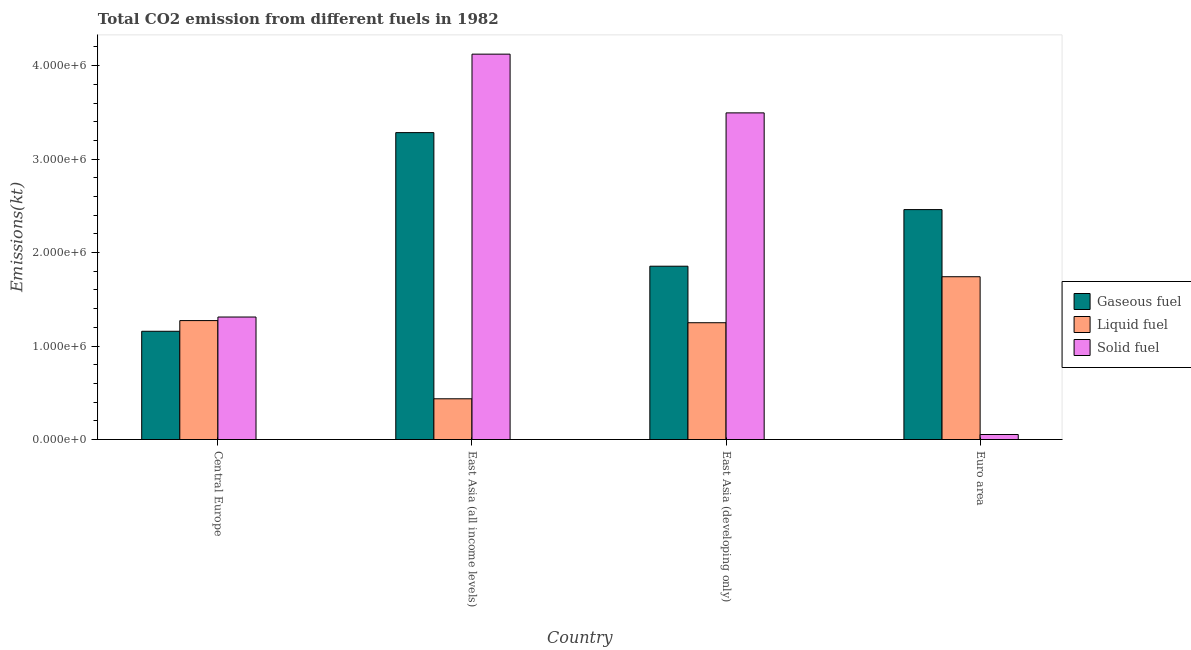How many different coloured bars are there?
Make the answer very short. 3. Are the number of bars per tick equal to the number of legend labels?
Provide a succinct answer. Yes. How many bars are there on the 4th tick from the left?
Ensure brevity in your answer.  3. What is the label of the 1st group of bars from the left?
Offer a terse response. Central Europe. What is the amount of co2 emissions from liquid fuel in East Asia (all income levels)?
Your response must be concise. 4.36e+05. Across all countries, what is the maximum amount of co2 emissions from solid fuel?
Your response must be concise. 4.12e+06. Across all countries, what is the minimum amount of co2 emissions from gaseous fuel?
Offer a terse response. 1.16e+06. In which country was the amount of co2 emissions from solid fuel maximum?
Give a very brief answer. East Asia (all income levels). In which country was the amount of co2 emissions from liquid fuel minimum?
Your answer should be very brief. East Asia (all income levels). What is the total amount of co2 emissions from solid fuel in the graph?
Ensure brevity in your answer.  8.98e+06. What is the difference between the amount of co2 emissions from liquid fuel in East Asia (all income levels) and that in Euro area?
Give a very brief answer. -1.31e+06. What is the difference between the amount of co2 emissions from gaseous fuel in Euro area and the amount of co2 emissions from liquid fuel in Central Europe?
Keep it short and to the point. 1.19e+06. What is the average amount of co2 emissions from gaseous fuel per country?
Keep it short and to the point. 2.19e+06. What is the difference between the amount of co2 emissions from liquid fuel and amount of co2 emissions from gaseous fuel in Euro area?
Provide a short and direct response. -7.18e+05. In how many countries, is the amount of co2 emissions from liquid fuel greater than 2800000 kt?
Offer a terse response. 0. What is the ratio of the amount of co2 emissions from solid fuel in East Asia (all income levels) to that in East Asia (developing only)?
Provide a short and direct response. 1.18. Is the amount of co2 emissions from solid fuel in East Asia (developing only) less than that in Euro area?
Offer a terse response. No. What is the difference between the highest and the second highest amount of co2 emissions from solid fuel?
Offer a terse response. 6.28e+05. What is the difference between the highest and the lowest amount of co2 emissions from liquid fuel?
Offer a terse response. 1.31e+06. Is the sum of the amount of co2 emissions from liquid fuel in Central Europe and East Asia (all income levels) greater than the maximum amount of co2 emissions from solid fuel across all countries?
Give a very brief answer. No. What does the 2nd bar from the left in Central Europe represents?
Your response must be concise. Liquid fuel. What does the 3rd bar from the right in East Asia (developing only) represents?
Make the answer very short. Gaseous fuel. How many bars are there?
Your response must be concise. 12. Are all the bars in the graph horizontal?
Offer a very short reply. No. How many countries are there in the graph?
Give a very brief answer. 4. Are the values on the major ticks of Y-axis written in scientific E-notation?
Your answer should be compact. Yes. Where does the legend appear in the graph?
Provide a short and direct response. Center right. How many legend labels are there?
Provide a succinct answer. 3. What is the title of the graph?
Your answer should be compact. Total CO2 emission from different fuels in 1982. Does "Total employers" appear as one of the legend labels in the graph?
Offer a very short reply. No. What is the label or title of the Y-axis?
Your response must be concise. Emissions(kt). What is the Emissions(kt) in Gaseous fuel in Central Europe?
Your response must be concise. 1.16e+06. What is the Emissions(kt) in Liquid fuel in Central Europe?
Your response must be concise. 1.27e+06. What is the Emissions(kt) in Solid fuel in Central Europe?
Your response must be concise. 1.31e+06. What is the Emissions(kt) of Gaseous fuel in East Asia (all income levels)?
Ensure brevity in your answer.  3.28e+06. What is the Emissions(kt) in Liquid fuel in East Asia (all income levels)?
Make the answer very short. 4.36e+05. What is the Emissions(kt) of Solid fuel in East Asia (all income levels)?
Offer a very short reply. 4.12e+06. What is the Emissions(kt) in Gaseous fuel in East Asia (developing only)?
Your answer should be very brief. 1.85e+06. What is the Emissions(kt) in Liquid fuel in East Asia (developing only)?
Offer a very short reply. 1.25e+06. What is the Emissions(kt) in Solid fuel in East Asia (developing only)?
Your answer should be very brief. 3.49e+06. What is the Emissions(kt) in Gaseous fuel in Euro area?
Provide a succinct answer. 2.46e+06. What is the Emissions(kt) of Liquid fuel in Euro area?
Offer a very short reply. 1.74e+06. What is the Emissions(kt) of Solid fuel in Euro area?
Your answer should be very brief. 5.37e+04. Across all countries, what is the maximum Emissions(kt) in Gaseous fuel?
Ensure brevity in your answer.  3.28e+06. Across all countries, what is the maximum Emissions(kt) in Liquid fuel?
Make the answer very short. 1.74e+06. Across all countries, what is the maximum Emissions(kt) of Solid fuel?
Provide a succinct answer. 4.12e+06. Across all countries, what is the minimum Emissions(kt) in Gaseous fuel?
Your answer should be very brief. 1.16e+06. Across all countries, what is the minimum Emissions(kt) of Liquid fuel?
Offer a very short reply. 4.36e+05. Across all countries, what is the minimum Emissions(kt) in Solid fuel?
Offer a terse response. 5.37e+04. What is the total Emissions(kt) of Gaseous fuel in the graph?
Your answer should be compact. 8.76e+06. What is the total Emissions(kt) in Liquid fuel in the graph?
Keep it short and to the point. 4.70e+06. What is the total Emissions(kt) in Solid fuel in the graph?
Ensure brevity in your answer.  8.98e+06. What is the difference between the Emissions(kt) in Gaseous fuel in Central Europe and that in East Asia (all income levels)?
Make the answer very short. -2.13e+06. What is the difference between the Emissions(kt) of Liquid fuel in Central Europe and that in East Asia (all income levels)?
Make the answer very short. 8.37e+05. What is the difference between the Emissions(kt) in Solid fuel in Central Europe and that in East Asia (all income levels)?
Make the answer very short. -2.81e+06. What is the difference between the Emissions(kt) of Gaseous fuel in Central Europe and that in East Asia (developing only)?
Make the answer very short. -6.96e+05. What is the difference between the Emissions(kt) in Liquid fuel in Central Europe and that in East Asia (developing only)?
Give a very brief answer. 2.29e+04. What is the difference between the Emissions(kt) of Solid fuel in Central Europe and that in East Asia (developing only)?
Offer a terse response. -2.18e+06. What is the difference between the Emissions(kt) in Gaseous fuel in Central Europe and that in Euro area?
Keep it short and to the point. -1.30e+06. What is the difference between the Emissions(kt) of Liquid fuel in Central Europe and that in Euro area?
Your response must be concise. -4.69e+05. What is the difference between the Emissions(kt) in Solid fuel in Central Europe and that in Euro area?
Your answer should be compact. 1.26e+06. What is the difference between the Emissions(kt) of Gaseous fuel in East Asia (all income levels) and that in East Asia (developing only)?
Provide a succinct answer. 1.43e+06. What is the difference between the Emissions(kt) of Liquid fuel in East Asia (all income levels) and that in East Asia (developing only)?
Make the answer very short. -8.14e+05. What is the difference between the Emissions(kt) in Solid fuel in East Asia (all income levels) and that in East Asia (developing only)?
Your answer should be very brief. 6.28e+05. What is the difference between the Emissions(kt) of Gaseous fuel in East Asia (all income levels) and that in Euro area?
Offer a very short reply. 8.24e+05. What is the difference between the Emissions(kt) in Liquid fuel in East Asia (all income levels) and that in Euro area?
Provide a succinct answer. -1.31e+06. What is the difference between the Emissions(kt) in Solid fuel in East Asia (all income levels) and that in Euro area?
Ensure brevity in your answer.  4.07e+06. What is the difference between the Emissions(kt) in Gaseous fuel in East Asia (developing only) and that in Euro area?
Make the answer very short. -6.06e+05. What is the difference between the Emissions(kt) in Liquid fuel in East Asia (developing only) and that in Euro area?
Keep it short and to the point. -4.92e+05. What is the difference between the Emissions(kt) of Solid fuel in East Asia (developing only) and that in Euro area?
Make the answer very short. 3.44e+06. What is the difference between the Emissions(kt) in Gaseous fuel in Central Europe and the Emissions(kt) in Liquid fuel in East Asia (all income levels)?
Your response must be concise. 7.22e+05. What is the difference between the Emissions(kt) in Gaseous fuel in Central Europe and the Emissions(kt) in Solid fuel in East Asia (all income levels)?
Provide a succinct answer. -2.96e+06. What is the difference between the Emissions(kt) in Liquid fuel in Central Europe and the Emissions(kt) in Solid fuel in East Asia (all income levels)?
Your response must be concise. -2.85e+06. What is the difference between the Emissions(kt) of Gaseous fuel in Central Europe and the Emissions(kt) of Liquid fuel in East Asia (developing only)?
Provide a short and direct response. -9.14e+04. What is the difference between the Emissions(kt) of Gaseous fuel in Central Europe and the Emissions(kt) of Solid fuel in East Asia (developing only)?
Your response must be concise. -2.34e+06. What is the difference between the Emissions(kt) in Liquid fuel in Central Europe and the Emissions(kt) in Solid fuel in East Asia (developing only)?
Provide a succinct answer. -2.22e+06. What is the difference between the Emissions(kt) in Gaseous fuel in Central Europe and the Emissions(kt) in Liquid fuel in Euro area?
Offer a terse response. -5.84e+05. What is the difference between the Emissions(kt) of Gaseous fuel in Central Europe and the Emissions(kt) of Solid fuel in Euro area?
Offer a terse response. 1.10e+06. What is the difference between the Emissions(kt) of Liquid fuel in Central Europe and the Emissions(kt) of Solid fuel in Euro area?
Your response must be concise. 1.22e+06. What is the difference between the Emissions(kt) in Gaseous fuel in East Asia (all income levels) and the Emissions(kt) in Liquid fuel in East Asia (developing only)?
Keep it short and to the point. 2.03e+06. What is the difference between the Emissions(kt) in Gaseous fuel in East Asia (all income levels) and the Emissions(kt) in Solid fuel in East Asia (developing only)?
Offer a terse response. -2.11e+05. What is the difference between the Emissions(kt) in Liquid fuel in East Asia (all income levels) and the Emissions(kt) in Solid fuel in East Asia (developing only)?
Offer a terse response. -3.06e+06. What is the difference between the Emissions(kt) in Gaseous fuel in East Asia (all income levels) and the Emissions(kt) in Liquid fuel in Euro area?
Give a very brief answer. 1.54e+06. What is the difference between the Emissions(kt) in Gaseous fuel in East Asia (all income levels) and the Emissions(kt) in Solid fuel in Euro area?
Your answer should be very brief. 3.23e+06. What is the difference between the Emissions(kt) in Liquid fuel in East Asia (all income levels) and the Emissions(kt) in Solid fuel in Euro area?
Your answer should be very brief. 3.82e+05. What is the difference between the Emissions(kt) in Gaseous fuel in East Asia (developing only) and the Emissions(kt) in Liquid fuel in Euro area?
Offer a terse response. 1.12e+05. What is the difference between the Emissions(kt) in Gaseous fuel in East Asia (developing only) and the Emissions(kt) in Solid fuel in Euro area?
Ensure brevity in your answer.  1.80e+06. What is the difference between the Emissions(kt) of Liquid fuel in East Asia (developing only) and the Emissions(kt) of Solid fuel in Euro area?
Provide a succinct answer. 1.20e+06. What is the average Emissions(kt) in Gaseous fuel per country?
Provide a short and direct response. 2.19e+06. What is the average Emissions(kt) of Liquid fuel per country?
Provide a succinct answer. 1.17e+06. What is the average Emissions(kt) of Solid fuel per country?
Keep it short and to the point. 2.25e+06. What is the difference between the Emissions(kt) in Gaseous fuel and Emissions(kt) in Liquid fuel in Central Europe?
Make the answer very short. -1.14e+05. What is the difference between the Emissions(kt) of Gaseous fuel and Emissions(kt) of Solid fuel in Central Europe?
Ensure brevity in your answer.  -1.52e+05. What is the difference between the Emissions(kt) of Liquid fuel and Emissions(kt) of Solid fuel in Central Europe?
Offer a terse response. -3.82e+04. What is the difference between the Emissions(kt) in Gaseous fuel and Emissions(kt) in Liquid fuel in East Asia (all income levels)?
Make the answer very short. 2.85e+06. What is the difference between the Emissions(kt) in Gaseous fuel and Emissions(kt) in Solid fuel in East Asia (all income levels)?
Offer a very short reply. -8.40e+05. What is the difference between the Emissions(kt) of Liquid fuel and Emissions(kt) of Solid fuel in East Asia (all income levels)?
Keep it short and to the point. -3.69e+06. What is the difference between the Emissions(kt) of Gaseous fuel and Emissions(kt) of Liquid fuel in East Asia (developing only)?
Offer a very short reply. 6.05e+05. What is the difference between the Emissions(kt) of Gaseous fuel and Emissions(kt) of Solid fuel in East Asia (developing only)?
Your answer should be very brief. -1.64e+06. What is the difference between the Emissions(kt) in Liquid fuel and Emissions(kt) in Solid fuel in East Asia (developing only)?
Offer a very short reply. -2.25e+06. What is the difference between the Emissions(kt) in Gaseous fuel and Emissions(kt) in Liquid fuel in Euro area?
Keep it short and to the point. 7.18e+05. What is the difference between the Emissions(kt) of Gaseous fuel and Emissions(kt) of Solid fuel in Euro area?
Offer a terse response. 2.41e+06. What is the difference between the Emissions(kt) of Liquid fuel and Emissions(kt) of Solid fuel in Euro area?
Your answer should be compact. 1.69e+06. What is the ratio of the Emissions(kt) in Gaseous fuel in Central Europe to that in East Asia (all income levels)?
Offer a terse response. 0.35. What is the ratio of the Emissions(kt) of Liquid fuel in Central Europe to that in East Asia (all income levels)?
Give a very brief answer. 2.92. What is the ratio of the Emissions(kt) in Solid fuel in Central Europe to that in East Asia (all income levels)?
Provide a short and direct response. 0.32. What is the ratio of the Emissions(kt) of Gaseous fuel in Central Europe to that in East Asia (developing only)?
Ensure brevity in your answer.  0.62. What is the ratio of the Emissions(kt) of Liquid fuel in Central Europe to that in East Asia (developing only)?
Ensure brevity in your answer.  1.02. What is the ratio of the Emissions(kt) in Gaseous fuel in Central Europe to that in Euro area?
Your response must be concise. 0.47. What is the ratio of the Emissions(kt) in Liquid fuel in Central Europe to that in Euro area?
Make the answer very short. 0.73. What is the ratio of the Emissions(kt) of Solid fuel in Central Europe to that in Euro area?
Keep it short and to the point. 24.41. What is the ratio of the Emissions(kt) of Gaseous fuel in East Asia (all income levels) to that in East Asia (developing only)?
Provide a short and direct response. 1.77. What is the ratio of the Emissions(kt) of Liquid fuel in East Asia (all income levels) to that in East Asia (developing only)?
Your answer should be very brief. 0.35. What is the ratio of the Emissions(kt) of Solid fuel in East Asia (all income levels) to that in East Asia (developing only)?
Offer a very short reply. 1.18. What is the ratio of the Emissions(kt) in Gaseous fuel in East Asia (all income levels) to that in Euro area?
Make the answer very short. 1.33. What is the ratio of the Emissions(kt) of Liquid fuel in East Asia (all income levels) to that in Euro area?
Your answer should be very brief. 0.25. What is the ratio of the Emissions(kt) of Solid fuel in East Asia (all income levels) to that in Euro area?
Ensure brevity in your answer.  76.8. What is the ratio of the Emissions(kt) of Gaseous fuel in East Asia (developing only) to that in Euro area?
Your response must be concise. 0.75. What is the ratio of the Emissions(kt) of Liquid fuel in East Asia (developing only) to that in Euro area?
Your answer should be very brief. 0.72. What is the ratio of the Emissions(kt) in Solid fuel in East Asia (developing only) to that in Euro area?
Your response must be concise. 65.09. What is the difference between the highest and the second highest Emissions(kt) of Gaseous fuel?
Give a very brief answer. 8.24e+05. What is the difference between the highest and the second highest Emissions(kt) of Liquid fuel?
Your response must be concise. 4.69e+05. What is the difference between the highest and the second highest Emissions(kt) of Solid fuel?
Offer a very short reply. 6.28e+05. What is the difference between the highest and the lowest Emissions(kt) of Gaseous fuel?
Your response must be concise. 2.13e+06. What is the difference between the highest and the lowest Emissions(kt) in Liquid fuel?
Give a very brief answer. 1.31e+06. What is the difference between the highest and the lowest Emissions(kt) of Solid fuel?
Make the answer very short. 4.07e+06. 